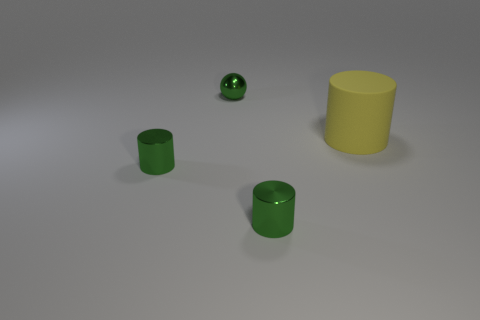Is there any other thing that is the same shape as the large yellow object?
Make the answer very short. Yes. Is the number of tiny metal objects that are in front of the big cylinder the same as the number of small green cylinders left of the tiny sphere?
Your answer should be compact. No. What number of cylinders are large matte objects or tiny metallic things?
Offer a terse response. 3. How many other things are the same material as the yellow object?
Your answer should be very brief. 0. What is the shape of the green thing behind the big rubber cylinder?
Your answer should be compact. Sphere. There is a cylinder that is on the left side of the small green ball that is on the left side of the matte cylinder; what is its material?
Make the answer very short. Metal. Is the number of rubber cylinders in front of the big cylinder greater than the number of green shiny objects?
Keep it short and to the point. No. How many other objects are the same color as the big rubber cylinder?
Offer a very short reply. 0. What number of big things are on the left side of the green thing that is right of the green thing behind the big rubber cylinder?
Ensure brevity in your answer.  0. What number of rubber objects are green cylinders or purple cylinders?
Your answer should be very brief. 0. 